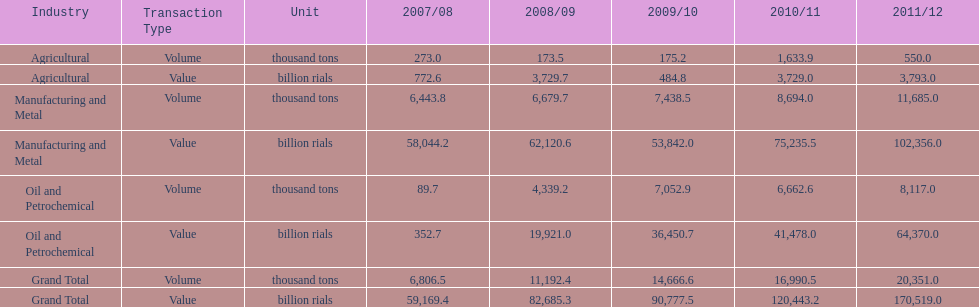Did 2010/11 or 2011/12 make more in grand total value? 2011/12. 